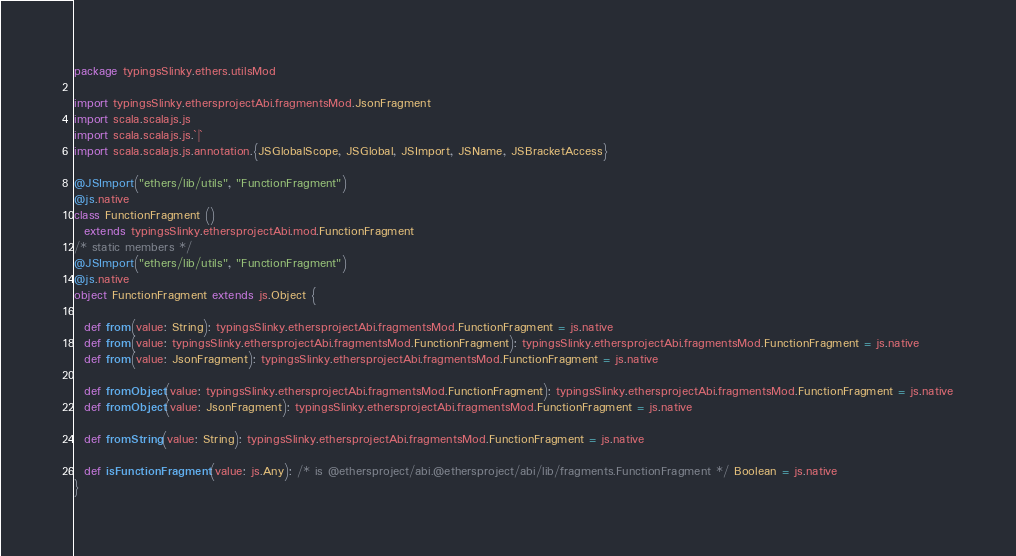<code> <loc_0><loc_0><loc_500><loc_500><_Scala_>package typingsSlinky.ethers.utilsMod

import typingsSlinky.ethersprojectAbi.fragmentsMod.JsonFragment
import scala.scalajs.js
import scala.scalajs.js.`|`
import scala.scalajs.js.annotation.{JSGlobalScope, JSGlobal, JSImport, JSName, JSBracketAccess}

@JSImport("ethers/lib/utils", "FunctionFragment")
@js.native
class FunctionFragment ()
  extends typingsSlinky.ethersprojectAbi.mod.FunctionFragment
/* static members */
@JSImport("ethers/lib/utils", "FunctionFragment")
@js.native
object FunctionFragment extends js.Object {
  
  def from(value: String): typingsSlinky.ethersprojectAbi.fragmentsMod.FunctionFragment = js.native
  def from(value: typingsSlinky.ethersprojectAbi.fragmentsMod.FunctionFragment): typingsSlinky.ethersprojectAbi.fragmentsMod.FunctionFragment = js.native
  def from(value: JsonFragment): typingsSlinky.ethersprojectAbi.fragmentsMod.FunctionFragment = js.native
  
  def fromObject(value: typingsSlinky.ethersprojectAbi.fragmentsMod.FunctionFragment): typingsSlinky.ethersprojectAbi.fragmentsMod.FunctionFragment = js.native
  def fromObject(value: JsonFragment): typingsSlinky.ethersprojectAbi.fragmentsMod.FunctionFragment = js.native
  
  def fromString(value: String): typingsSlinky.ethersprojectAbi.fragmentsMod.FunctionFragment = js.native
  
  def isFunctionFragment(value: js.Any): /* is @ethersproject/abi.@ethersproject/abi/lib/fragments.FunctionFragment */ Boolean = js.native
}
</code> 